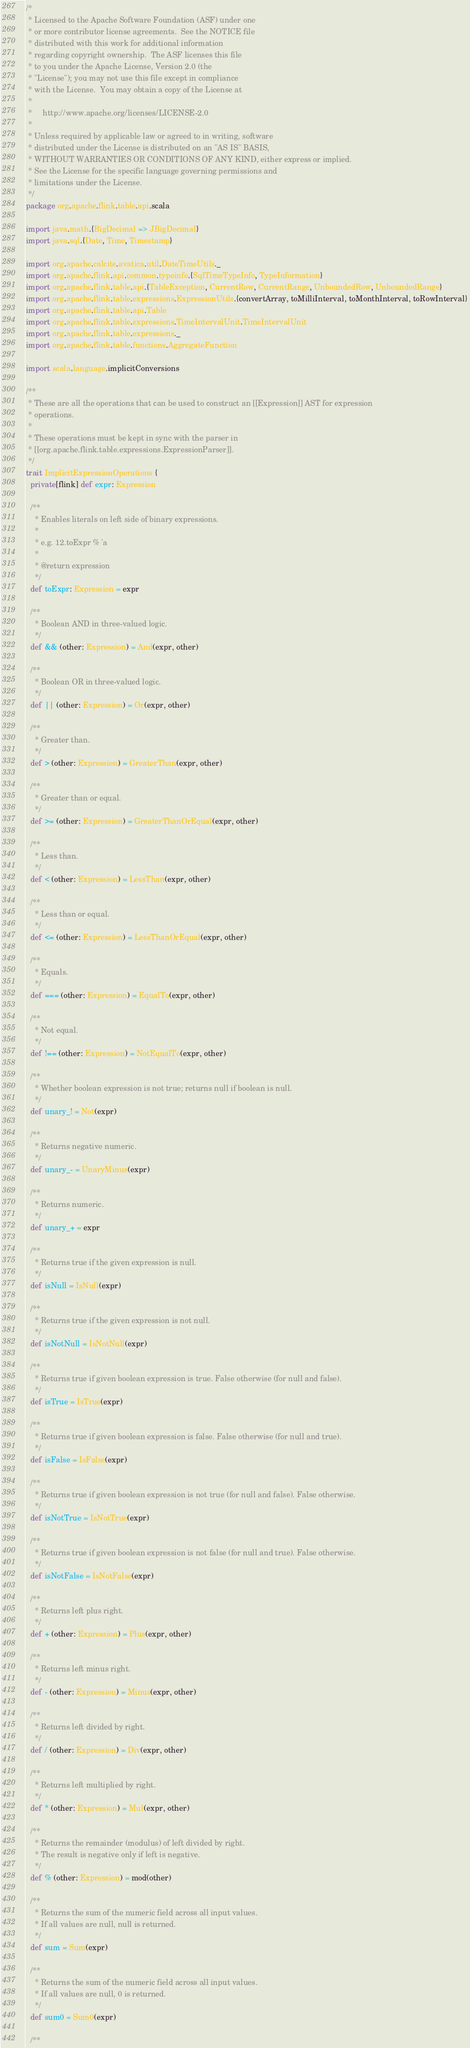<code> <loc_0><loc_0><loc_500><loc_500><_Scala_>/*
 * Licensed to the Apache Software Foundation (ASF) under one
 * or more contributor license agreements.  See the NOTICE file
 * distributed with this work for additional information
 * regarding copyright ownership.  The ASF licenses this file
 * to you under the Apache License, Version 2.0 (the
 * "License"); you may not use this file except in compliance
 * with the License.  You may obtain a copy of the License at
 *
 *     http://www.apache.org/licenses/LICENSE-2.0
 *
 * Unless required by applicable law or agreed to in writing, software
 * distributed under the License is distributed on an "AS IS" BASIS,
 * WITHOUT WARRANTIES OR CONDITIONS OF ANY KIND, either express or implied.
 * See the License for the specific language governing permissions and
 * limitations under the License.
 */
package org.apache.flink.table.api.scala

import java.math.{BigDecimal => JBigDecimal}
import java.sql.{Date, Time, Timestamp}

import org.apache.calcite.avatica.util.DateTimeUtils._
import org.apache.flink.api.common.typeinfo.{SqlTimeTypeInfo, TypeInformation}
import org.apache.flink.table.api.{TableException, CurrentRow, CurrentRange, UnboundedRow, UnboundedRange}
import org.apache.flink.table.expressions.ExpressionUtils.{convertArray, toMilliInterval, toMonthInterval, toRowInterval}
import org.apache.flink.table.api.Table
import org.apache.flink.table.expressions.TimeIntervalUnit.TimeIntervalUnit
import org.apache.flink.table.expressions._
import org.apache.flink.table.functions.AggregateFunction

import scala.language.implicitConversions

/**
 * These are all the operations that can be used to construct an [[Expression]] AST for expression
 * operations.
 *
 * These operations must be kept in sync with the parser in
 * [[org.apache.flink.table.expressions.ExpressionParser]].
 */
trait ImplicitExpressionOperations {
  private[flink] def expr: Expression

  /**
    * Enables literals on left side of binary expressions.
    *
    * e.g. 12.toExpr % 'a
    *
    * @return expression
    */
  def toExpr: Expression = expr

  /**
    * Boolean AND in three-valued logic.
    */
  def && (other: Expression) = And(expr, other)

  /**
    * Boolean OR in three-valued logic.
    */
  def || (other: Expression) = Or(expr, other)

  /**
    * Greater than.
    */
  def > (other: Expression) = GreaterThan(expr, other)

  /**
    * Greater than or equal.
    */
  def >= (other: Expression) = GreaterThanOrEqual(expr, other)

  /**
    * Less than.
    */
  def < (other: Expression) = LessThan(expr, other)

  /**
    * Less than or equal.
    */
  def <= (other: Expression) = LessThanOrEqual(expr, other)

  /**
    * Equals.
    */
  def === (other: Expression) = EqualTo(expr, other)

  /**
    * Not equal.
    */
  def !== (other: Expression) = NotEqualTo(expr, other)

  /**
    * Whether boolean expression is not true; returns null if boolean is null.
    */
  def unary_! = Not(expr)

  /**
    * Returns negative numeric.
    */
  def unary_- = UnaryMinus(expr)

  /**
    * Returns numeric.
    */
  def unary_+ = expr

  /**
    * Returns true if the given expression is null.
    */
  def isNull = IsNull(expr)

  /**
    * Returns true if the given expression is not null.
    */
  def isNotNull = IsNotNull(expr)

  /**
    * Returns true if given boolean expression is true. False otherwise (for null and false).
    */
  def isTrue = IsTrue(expr)

  /**
    * Returns true if given boolean expression is false. False otherwise (for null and true).
    */
  def isFalse = IsFalse(expr)

  /**
    * Returns true if given boolean expression is not true (for null and false). False otherwise.
    */
  def isNotTrue = IsNotTrue(expr)

  /**
    * Returns true if given boolean expression is not false (for null and true). False otherwise.
    */
  def isNotFalse = IsNotFalse(expr)

  /**
    * Returns left plus right.
    */
  def + (other: Expression) = Plus(expr, other)

  /**
    * Returns left minus right.
    */
  def - (other: Expression) = Minus(expr, other)

  /**
    * Returns left divided by right.
    */
  def / (other: Expression) = Div(expr, other)

  /**
    * Returns left multiplied by right.
    */
  def * (other: Expression) = Mul(expr, other)

  /**
    * Returns the remainder (modulus) of left divided by right.
    * The result is negative only if left is negative.
    */
  def % (other: Expression) = mod(other)

  /**
    * Returns the sum of the numeric field across all input values.
    * If all values are null, null is returned.
    */
  def sum = Sum(expr)

  /**
    * Returns the sum of the numeric field across all input values.
    * If all values are null, 0 is returned.
    */
  def sum0 = Sum0(expr)
  
  /**</code> 